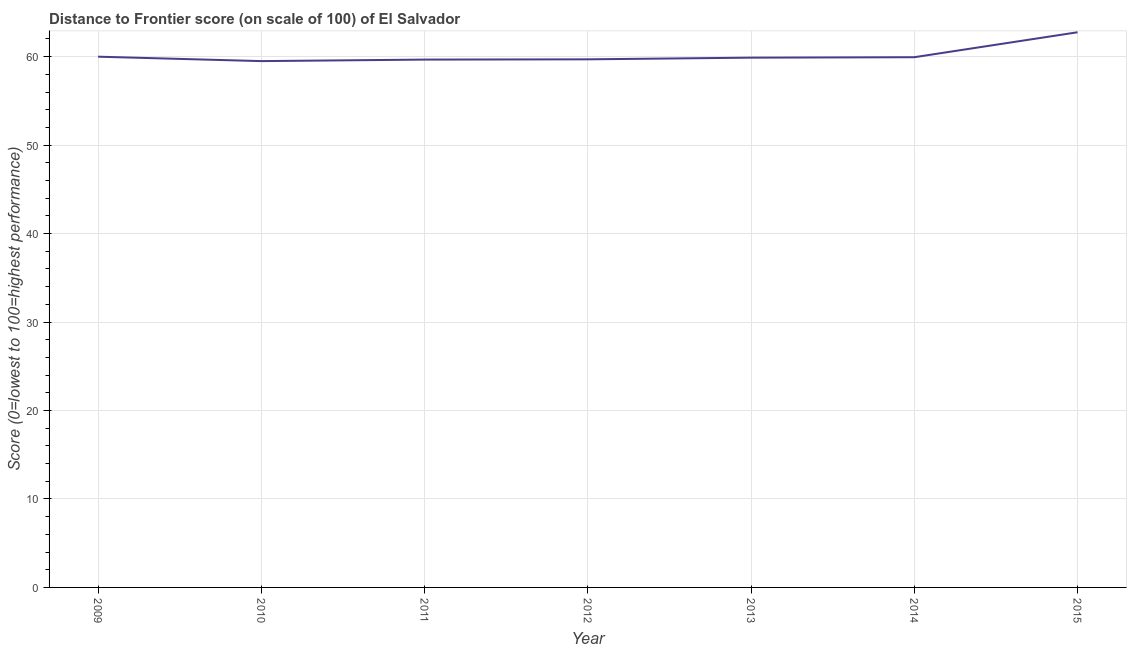What is the distance to frontier score in 2013?
Keep it short and to the point. 59.89. Across all years, what is the maximum distance to frontier score?
Offer a terse response. 62.76. Across all years, what is the minimum distance to frontier score?
Provide a succinct answer. 59.5. In which year was the distance to frontier score maximum?
Make the answer very short. 2015. In which year was the distance to frontier score minimum?
Provide a succinct answer. 2010. What is the sum of the distance to frontier score?
Your answer should be very brief. 421.46. What is the difference between the distance to frontier score in 2011 and 2013?
Provide a short and direct response. -0.22. What is the average distance to frontier score per year?
Your answer should be very brief. 60.21. What is the median distance to frontier score?
Provide a succinct answer. 59.89. In how many years, is the distance to frontier score greater than 38 ?
Your response must be concise. 7. Do a majority of the years between 2015 and 2011 (inclusive) have distance to frontier score greater than 34 ?
Your response must be concise. Yes. What is the ratio of the distance to frontier score in 2009 to that in 2015?
Your response must be concise. 0.96. Is the distance to frontier score in 2010 less than that in 2015?
Your response must be concise. Yes. Is the difference between the distance to frontier score in 2012 and 2014 greater than the difference between any two years?
Provide a succinct answer. No. What is the difference between the highest and the second highest distance to frontier score?
Provide a short and direct response. 2.76. Is the sum of the distance to frontier score in 2009 and 2013 greater than the maximum distance to frontier score across all years?
Your response must be concise. Yes. What is the difference between the highest and the lowest distance to frontier score?
Provide a succinct answer. 3.26. Does the distance to frontier score monotonically increase over the years?
Offer a very short reply. No. How many lines are there?
Offer a terse response. 1. How many years are there in the graph?
Offer a very short reply. 7. What is the difference between two consecutive major ticks on the Y-axis?
Provide a short and direct response. 10. Are the values on the major ticks of Y-axis written in scientific E-notation?
Your answer should be compact. No. What is the title of the graph?
Give a very brief answer. Distance to Frontier score (on scale of 100) of El Salvador. What is the label or title of the X-axis?
Your answer should be very brief. Year. What is the label or title of the Y-axis?
Provide a succinct answer. Score (0=lowest to 100=highest performance). What is the Score (0=lowest to 100=highest performance) in 2009?
Provide a short and direct response. 60. What is the Score (0=lowest to 100=highest performance) in 2010?
Your answer should be compact. 59.5. What is the Score (0=lowest to 100=highest performance) in 2011?
Give a very brief answer. 59.67. What is the Score (0=lowest to 100=highest performance) of 2012?
Your response must be concise. 59.7. What is the Score (0=lowest to 100=highest performance) in 2013?
Your answer should be very brief. 59.89. What is the Score (0=lowest to 100=highest performance) of 2014?
Make the answer very short. 59.94. What is the Score (0=lowest to 100=highest performance) in 2015?
Provide a short and direct response. 62.76. What is the difference between the Score (0=lowest to 100=highest performance) in 2009 and 2010?
Your answer should be very brief. 0.5. What is the difference between the Score (0=lowest to 100=highest performance) in 2009 and 2011?
Your answer should be compact. 0.33. What is the difference between the Score (0=lowest to 100=highest performance) in 2009 and 2012?
Ensure brevity in your answer.  0.3. What is the difference between the Score (0=lowest to 100=highest performance) in 2009 and 2013?
Make the answer very short. 0.11. What is the difference between the Score (0=lowest to 100=highest performance) in 2009 and 2014?
Ensure brevity in your answer.  0.06. What is the difference between the Score (0=lowest to 100=highest performance) in 2009 and 2015?
Your answer should be very brief. -2.76. What is the difference between the Score (0=lowest to 100=highest performance) in 2010 and 2011?
Provide a succinct answer. -0.17. What is the difference between the Score (0=lowest to 100=highest performance) in 2010 and 2013?
Your answer should be very brief. -0.39. What is the difference between the Score (0=lowest to 100=highest performance) in 2010 and 2014?
Make the answer very short. -0.44. What is the difference between the Score (0=lowest to 100=highest performance) in 2010 and 2015?
Ensure brevity in your answer.  -3.26. What is the difference between the Score (0=lowest to 100=highest performance) in 2011 and 2012?
Give a very brief answer. -0.03. What is the difference between the Score (0=lowest to 100=highest performance) in 2011 and 2013?
Make the answer very short. -0.22. What is the difference between the Score (0=lowest to 100=highest performance) in 2011 and 2014?
Make the answer very short. -0.27. What is the difference between the Score (0=lowest to 100=highest performance) in 2011 and 2015?
Give a very brief answer. -3.09. What is the difference between the Score (0=lowest to 100=highest performance) in 2012 and 2013?
Make the answer very short. -0.19. What is the difference between the Score (0=lowest to 100=highest performance) in 2012 and 2014?
Your answer should be very brief. -0.24. What is the difference between the Score (0=lowest to 100=highest performance) in 2012 and 2015?
Your response must be concise. -3.06. What is the difference between the Score (0=lowest to 100=highest performance) in 2013 and 2015?
Provide a succinct answer. -2.87. What is the difference between the Score (0=lowest to 100=highest performance) in 2014 and 2015?
Make the answer very short. -2.82. What is the ratio of the Score (0=lowest to 100=highest performance) in 2009 to that in 2010?
Make the answer very short. 1.01. What is the ratio of the Score (0=lowest to 100=highest performance) in 2009 to that in 2011?
Provide a succinct answer. 1.01. What is the ratio of the Score (0=lowest to 100=highest performance) in 2009 to that in 2014?
Provide a short and direct response. 1. What is the ratio of the Score (0=lowest to 100=highest performance) in 2009 to that in 2015?
Keep it short and to the point. 0.96. What is the ratio of the Score (0=lowest to 100=highest performance) in 2010 to that in 2011?
Your response must be concise. 1. What is the ratio of the Score (0=lowest to 100=highest performance) in 2010 to that in 2012?
Make the answer very short. 1. What is the ratio of the Score (0=lowest to 100=highest performance) in 2010 to that in 2013?
Your response must be concise. 0.99. What is the ratio of the Score (0=lowest to 100=highest performance) in 2010 to that in 2014?
Provide a succinct answer. 0.99. What is the ratio of the Score (0=lowest to 100=highest performance) in 2010 to that in 2015?
Provide a succinct answer. 0.95. What is the ratio of the Score (0=lowest to 100=highest performance) in 2011 to that in 2013?
Give a very brief answer. 1. What is the ratio of the Score (0=lowest to 100=highest performance) in 2011 to that in 2015?
Give a very brief answer. 0.95. What is the ratio of the Score (0=lowest to 100=highest performance) in 2012 to that in 2015?
Make the answer very short. 0.95. What is the ratio of the Score (0=lowest to 100=highest performance) in 2013 to that in 2014?
Ensure brevity in your answer.  1. What is the ratio of the Score (0=lowest to 100=highest performance) in 2013 to that in 2015?
Your response must be concise. 0.95. What is the ratio of the Score (0=lowest to 100=highest performance) in 2014 to that in 2015?
Give a very brief answer. 0.95. 